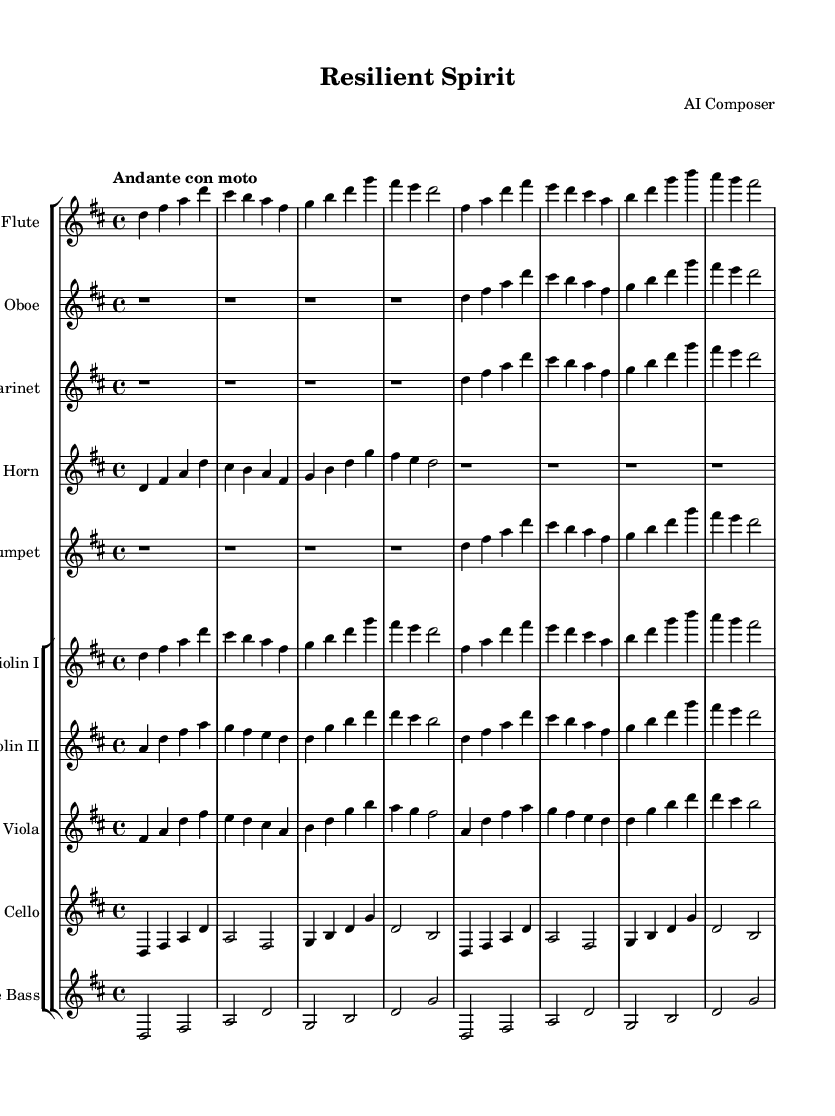What is the key signature of this music? The key signature is D major, which contains two sharps (F# and C#). This can be identified by looking at the beginning of the staff before the notes.
Answer: D major What is the time signature of this piece? The time signature is 4/4, represented by the two numbers on the left of the staff. The top number indicates four beats per measure, and the bottom number indicates a quarter note gets one beat.
Answer: 4/4 What is the tempo marking for this composition? The tempo marking is "Andante con moto," which suggests a moderately fast pace. This can be seen in the tempo indication above the staff.
Answer: Andante con moto How many measures are in the flute part? The flute part has eight measures, which can be counted as each set of notes and rests across the staff lines.
Answer: 8 Which instruments play during the first measure? In the first measure, only the flute plays, as indicated by the notation that begins on the flute staff without other instruments entering yet.
Answer: Flute What is the dynamic range of the oboe part? The oboe part does not show any specific dynamics, often implying a soft dynamic unless otherwise marked in the music sheet. The absence of markings suggests a range from very soft to moderately loud.
Answer: Soft In which section does the cello have a significant entrance? The cello makes a significant entrance in measure five, where it plays a melody, marking its importance in the orchestral texture at that point.
Answer: Measure five 